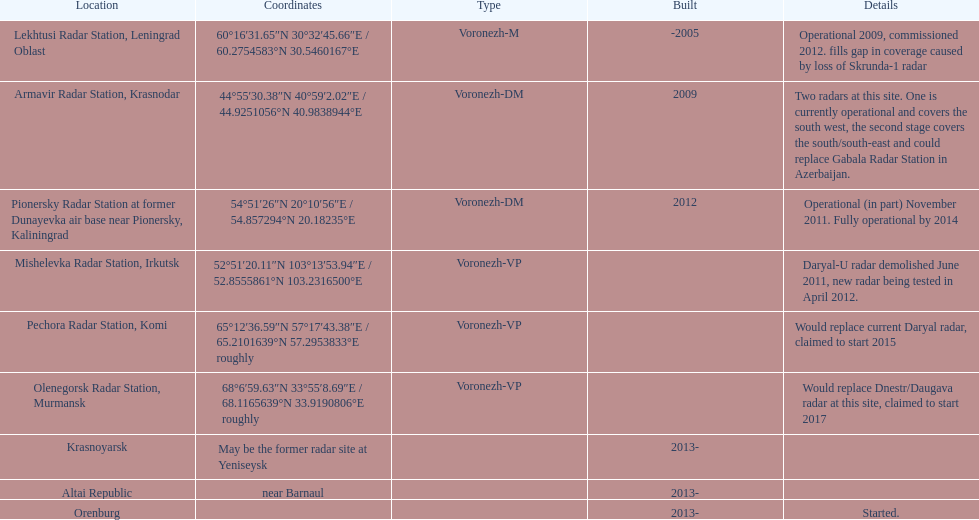At which spot can you find the coordinates 60°16'3 Lekhtusi Radar Station, Leningrad Oblast. 